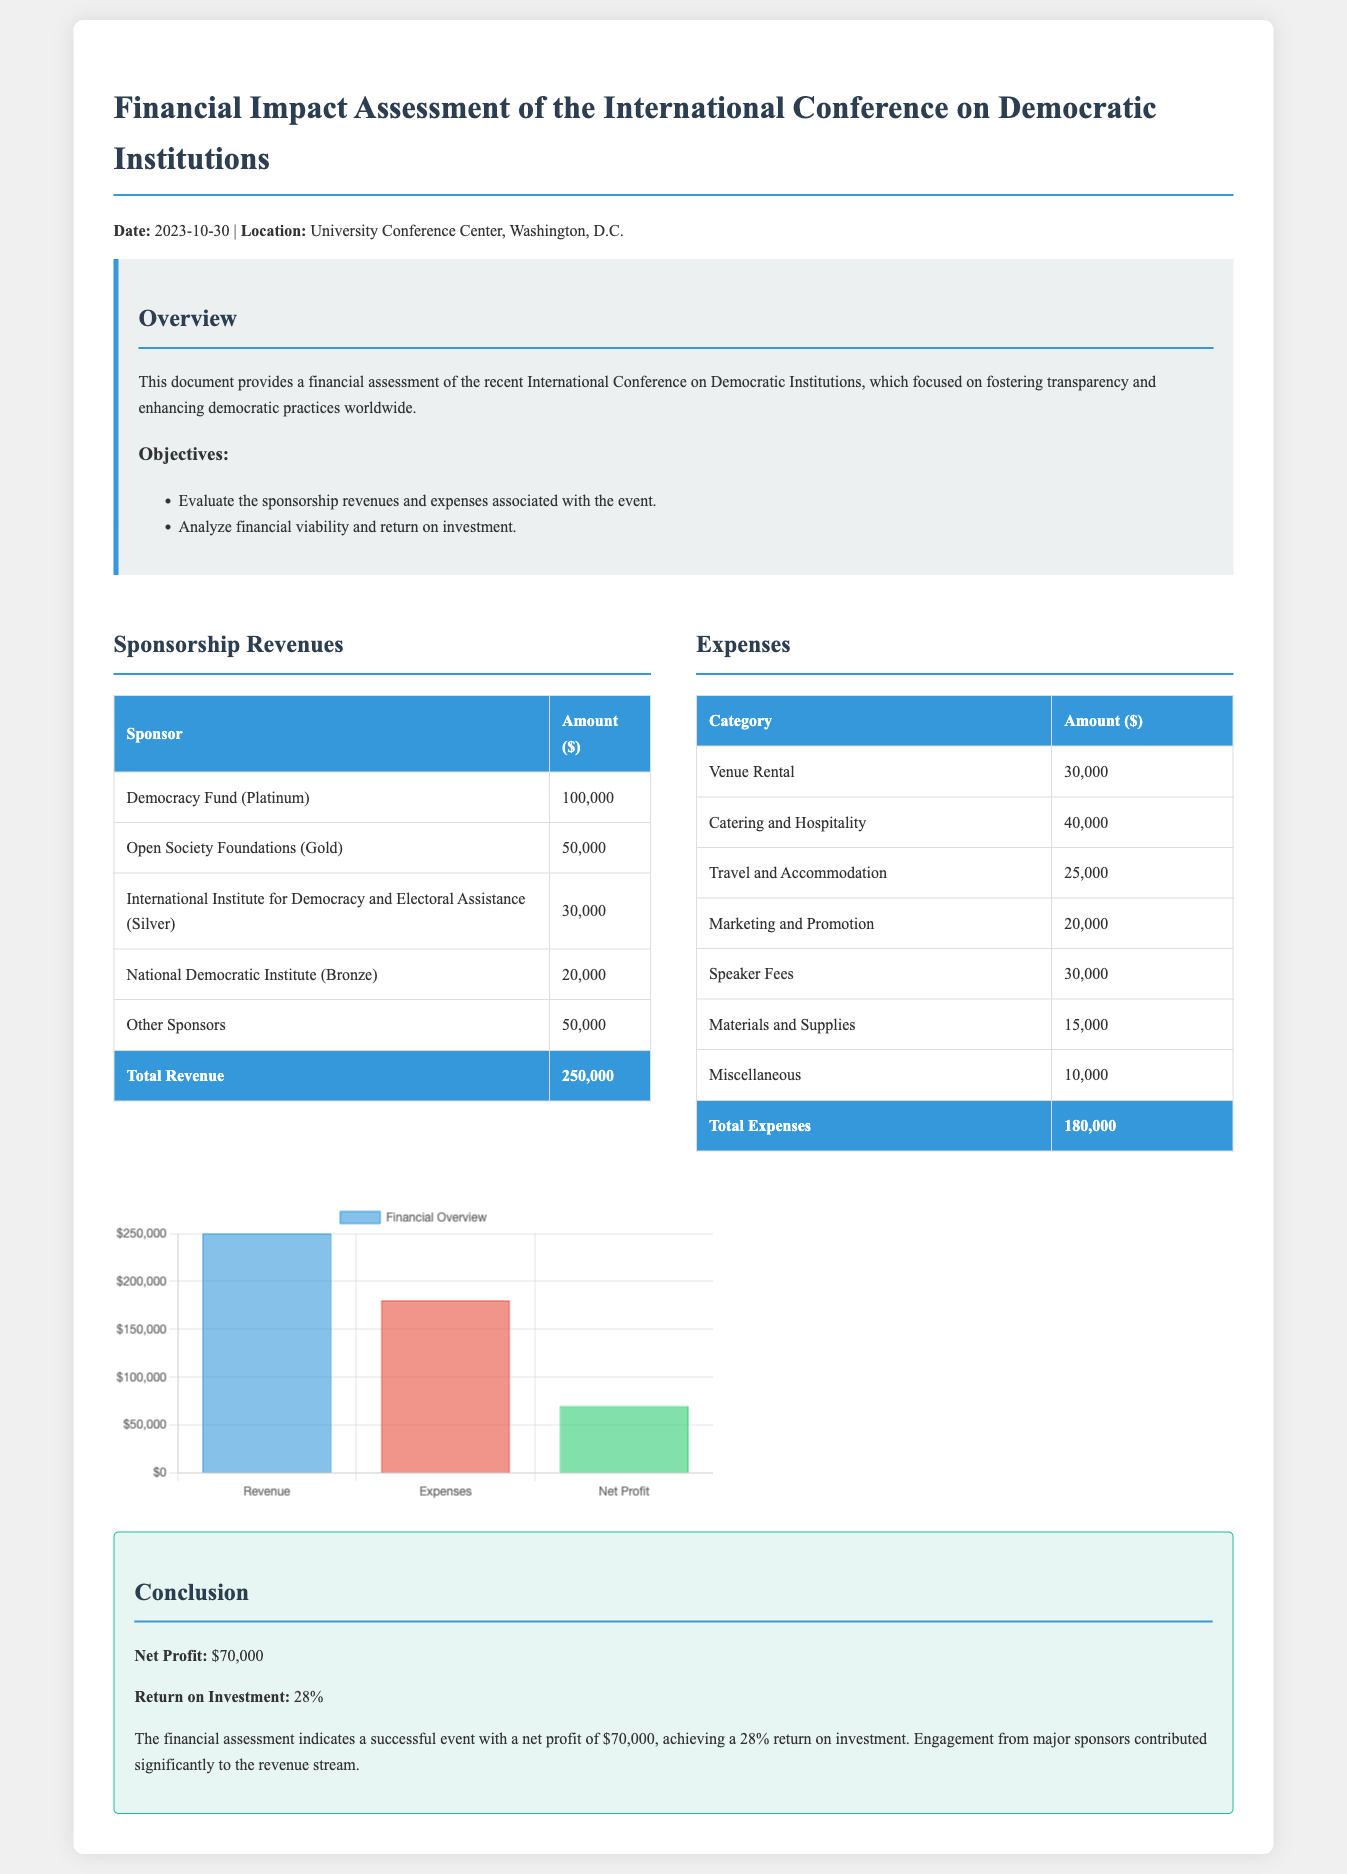What is the total revenue? The total revenue is listed at the end of the sponsorship revenues section as $250,000.
Answer: $250,000 What is the total expenses? The total expenses are provided in the expenses table, totaling $180,000.
Answer: $180,000 What is the net profit from the conference? The net profit is stated in the conclusion section as $70,000.
Answer: $70,000 What is the return on investment percentage? The return on investment is mentioned in the conclusion as 28%.
Answer: 28% Who was the platinum sponsor? The platinum sponsor is listed in the sponsorship revenues table as the Democracy Fund.
Answer: Democracy Fund How much did the Open Society Foundations contribute? The contribution from the Open Society Foundations is noted as $50,000 in the sponsorship revenues.
Answer: $50,000 What category had the highest expense? The highest expense category listed is Catering and Hospitality, amounting to $40,000.
Answer: Catering and Hospitality What was the venue rental cost? The venue rental cost is specified in the expenses table as $30,000.
Answer: $30,000 What was the date of the conference? The date of the conference is indicated at the beginning of the document as 2023-10-30.
Answer: 2023-10-30 